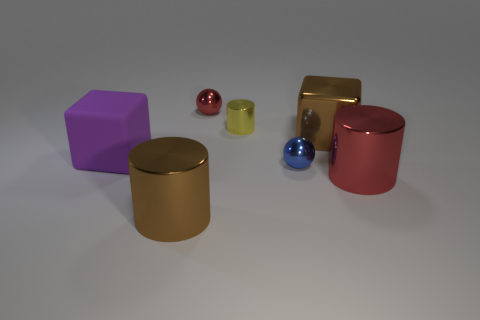What number of things are yellow metallic cylinders that are behind the small blue shiny thing or big brown objects?
Your response must be concise. 3. There is a large rubber thing on the left side of the big thing that is behind the large block to the left of the red ball; what is its shape?
Offer a terse response. Cube. How many large metallic objects have the same shape as the big purple rubber object?
Make the answer very short. 1. There is a big cylinder that is the same color as the metal cube; what is it made of?
Ensure brevity in your answer.  Metal. Do the small yellow cylinder and the red ball have the same material?
Your answer should be very brief. Yes. There is a brown object in front of the tiny metal sphere to the right of the tiny yellow shiny cylinder; what number of big red objects are to the right of it?
Provide a short and direct response. 1. Are there any red balls made of the same material as the tiny yellow object?
Your response must be concise. Yes. There is a cylinder that is the same color as the metal cube; what size is it?
Make the answer very short. Large. Is the number of tiny objects less than the number of big brown shiny spheres?
Give a very brief answer. No. There is a small ball behind the small blue metallic object; is its color the same as the big shiny cube?
Your answer should be compact. No. 